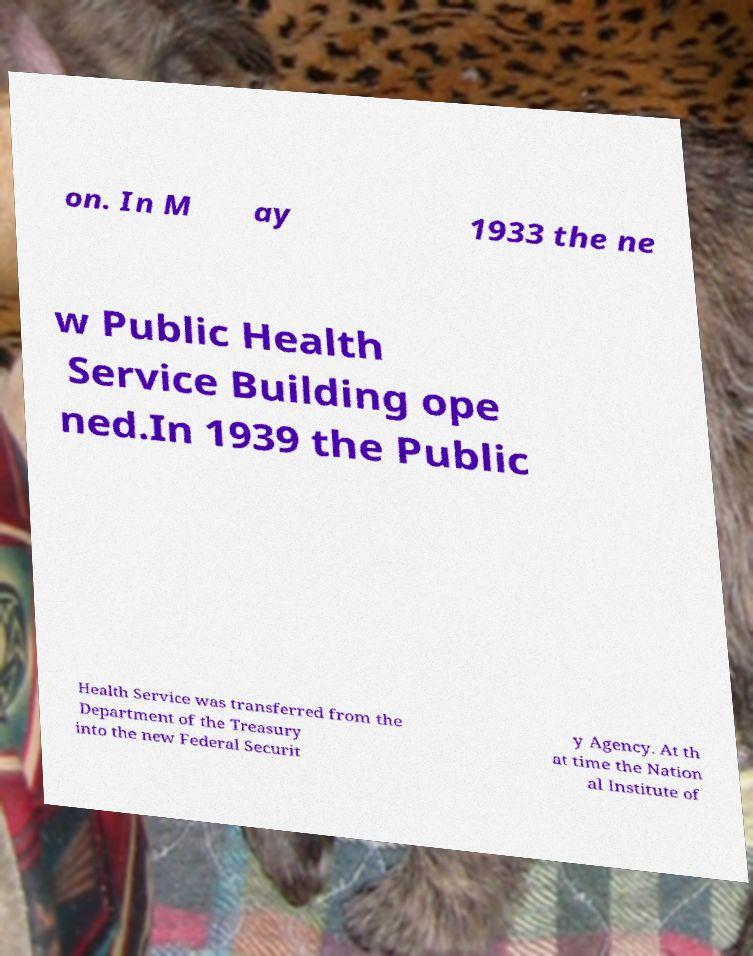Please read and relay the text visible in this image. What does it say? on. In M ay 1933 the ne w Public Health Service Building ope ned.In 1939 the Public Health Service was transferred from the Department of the Treasury into the new Federal Securit y Agency. At th at time the Nation al Institute of 